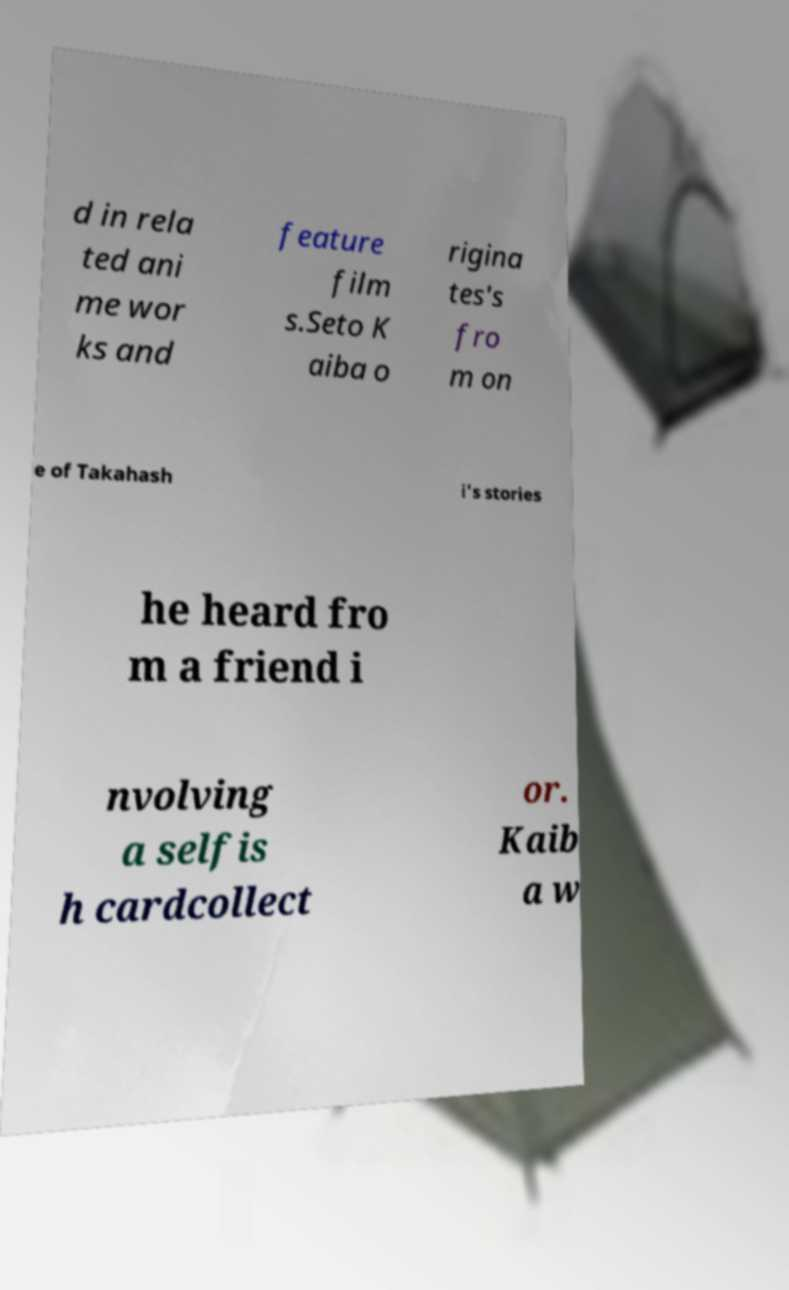Can you accurately transcribe the text from the provided image for me? d in rela ted ani me wor ks and feature film s.Seto K aiba o rigina tes's fro m on e of Takahash i's stories he heard fro m a friend i nvolving a selfis h cardcollect or. Kaib a w 